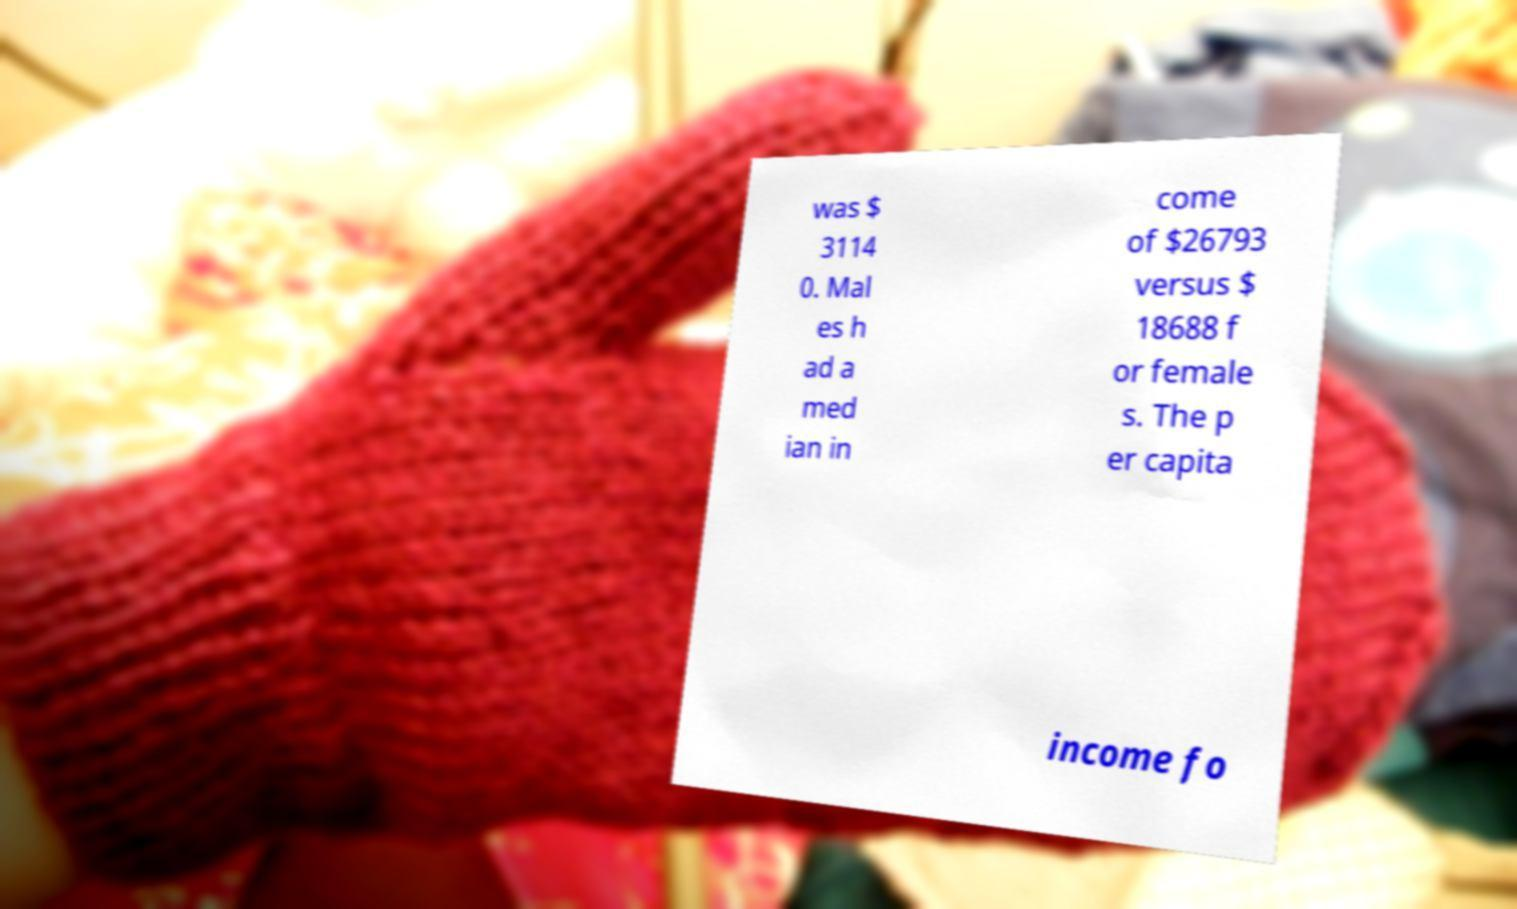Could you assist in decoding the text presented in this image and type it out clearly? was $ 3114 0. Mal es h ad a med ian in come of $26793 versus $ 18688 f or female s. The p er capita income fo 